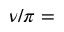<formula> <loc_0><loc_0><loc_500><loc_500>\nu / \pi =</formula> 